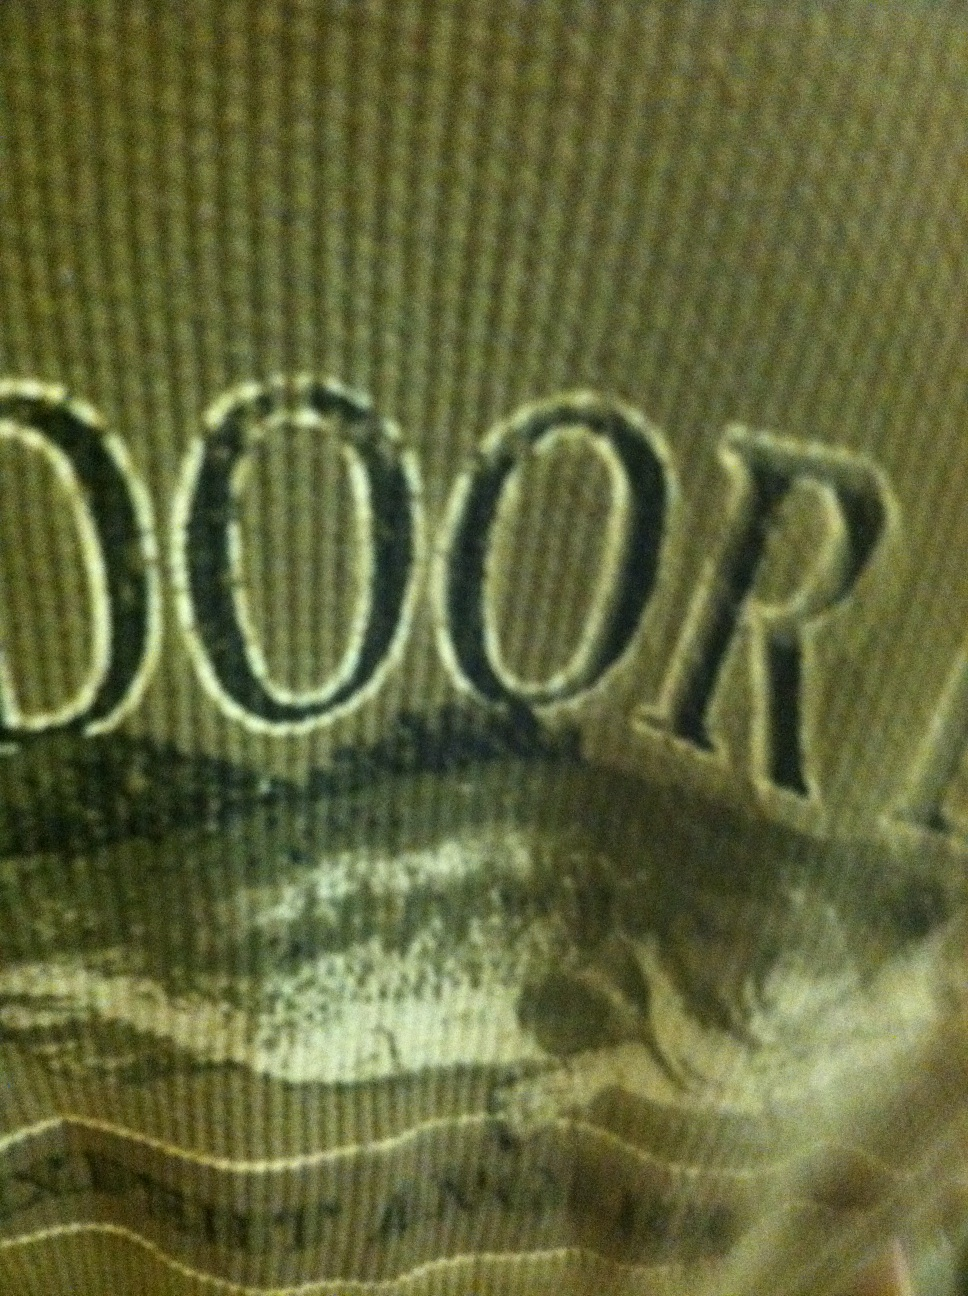Imagine a story about where this shirt has been worn. This green shirt, emblazoned with the word 'OUTDOOR', might have been worn on numerous adventurous excursions. Its wearer could have hiked up mountains, traversed dense forests, and camped under starry skies. Each thread of the shirt could tell tales of breathtaking views, encounters with wildlife, and the serenity of nature. 